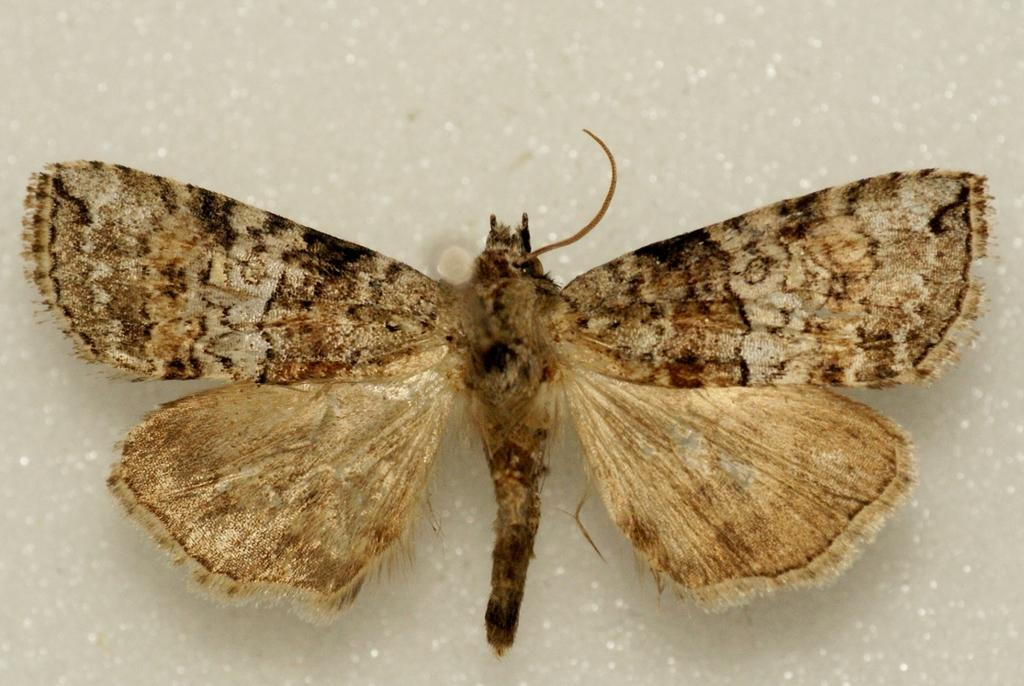What is the main subject in the image? There is a butterfly in the image. Where is the butterfly located in the image? The butterfly is on a path. What type of wax is the butterfly using to fly in the image? There is no wax mentioned or visible in the image, and butterflies do not use wax to fly. How does the wind affect the butterfly's flight in the image? There is no indication of wind in the image, and the butterfly's flight is not affected by any visible wind. 